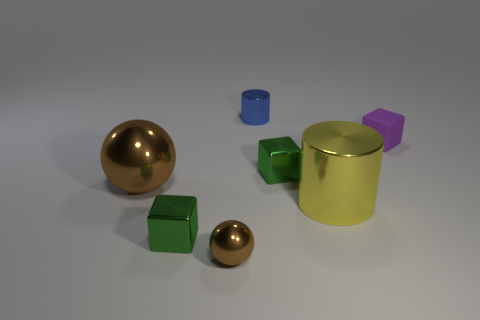Can you tell me what shapes are present in the image and their colors? Certainly! In the image, there is a large shiny golden ball, a smaller shiny golden ball, a green cube, a turquoise cylinder, a yellow cylinder, and a purple cube. 